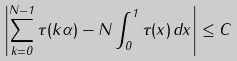Convert formula to latex. <formula><loc_0><loc_0><loc_500><loc_500>\left | \sum _ { k = 0 } ^ { N - 1 } \tau ( k \alpha ) - N \int _ { 0 } ^ { 1 } \tau ( x ) \, d x \right | \leq C</formula> 